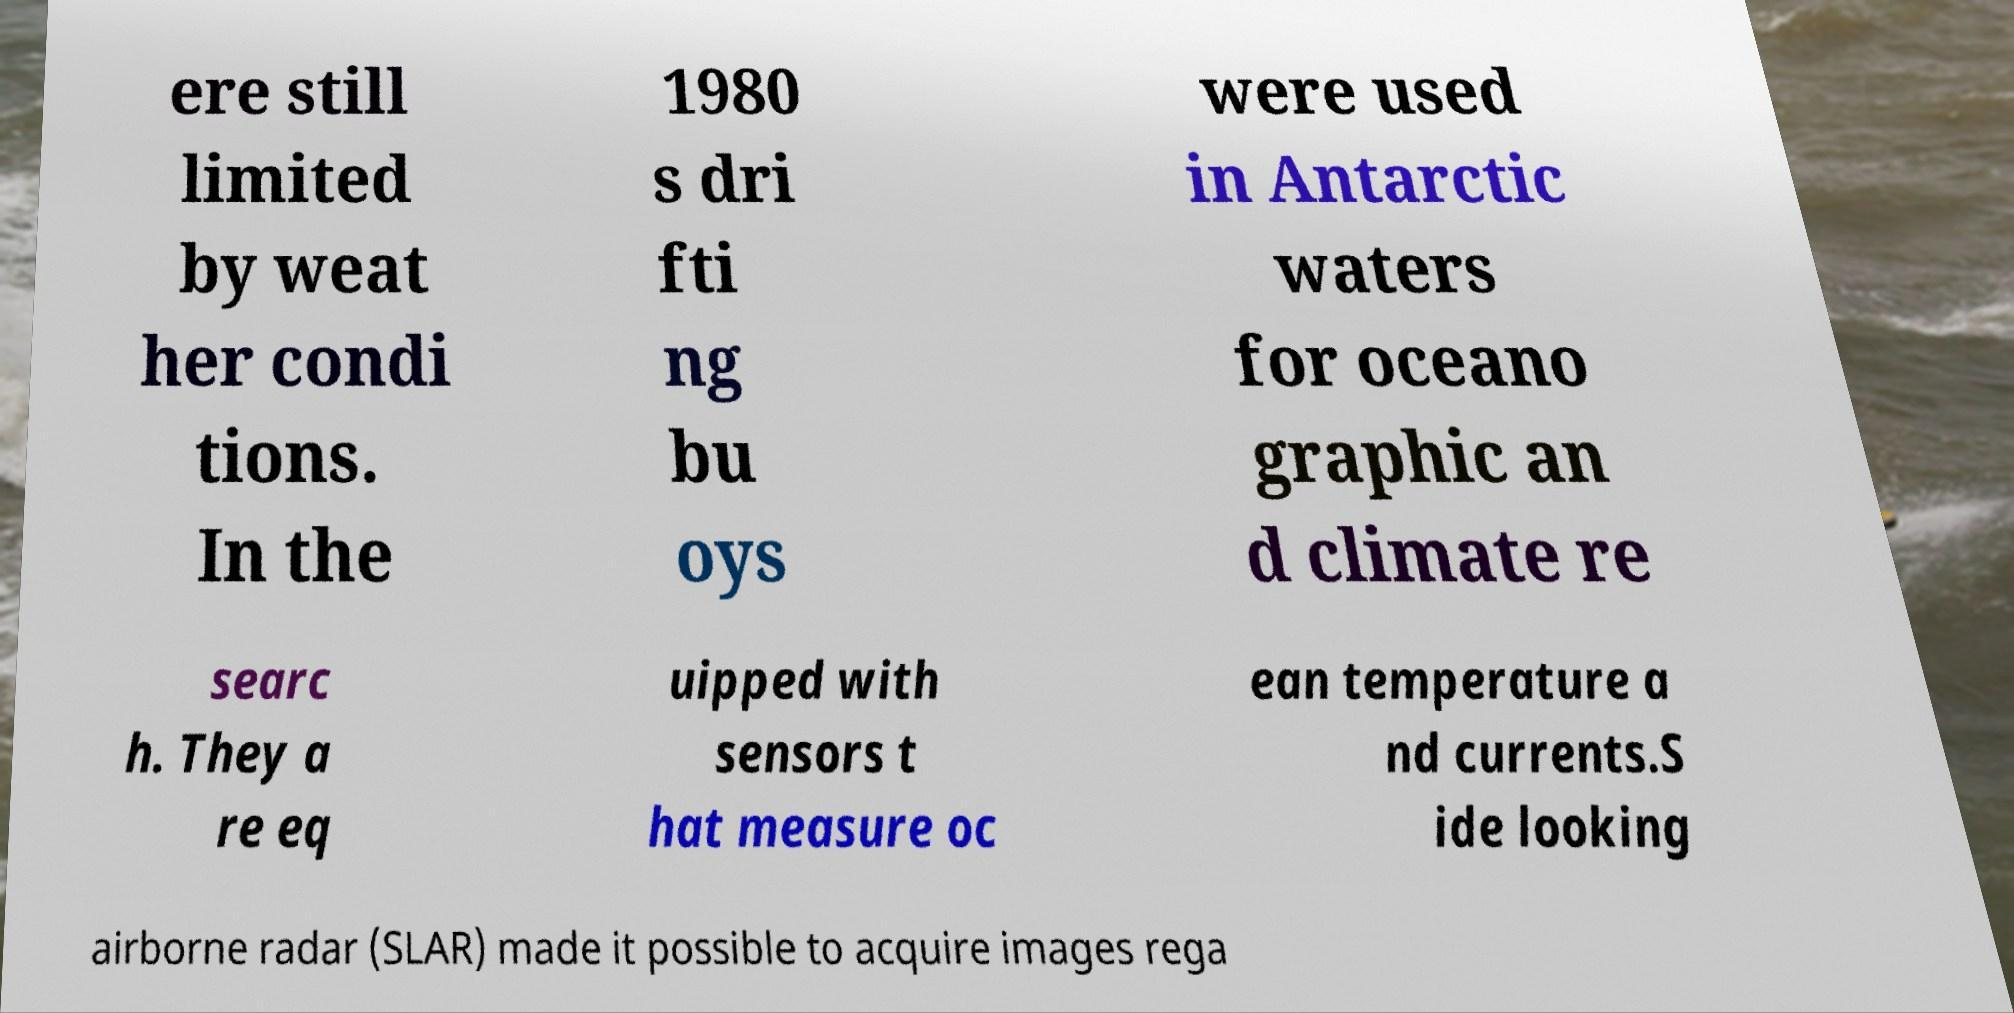What messages or text are displayed in this image? I need them in a readable, typed format. ere still limited by weat her condi tions. In the 1980 s dri fti ng bu oys were used in Antarctic waters for oceano graphic an d climate re searc h. They a re eq uipped with sensors t hat measure oc ean temperature a nd currents.S ide looking airborne radar (SLAR) made it possible to acquire images rega 